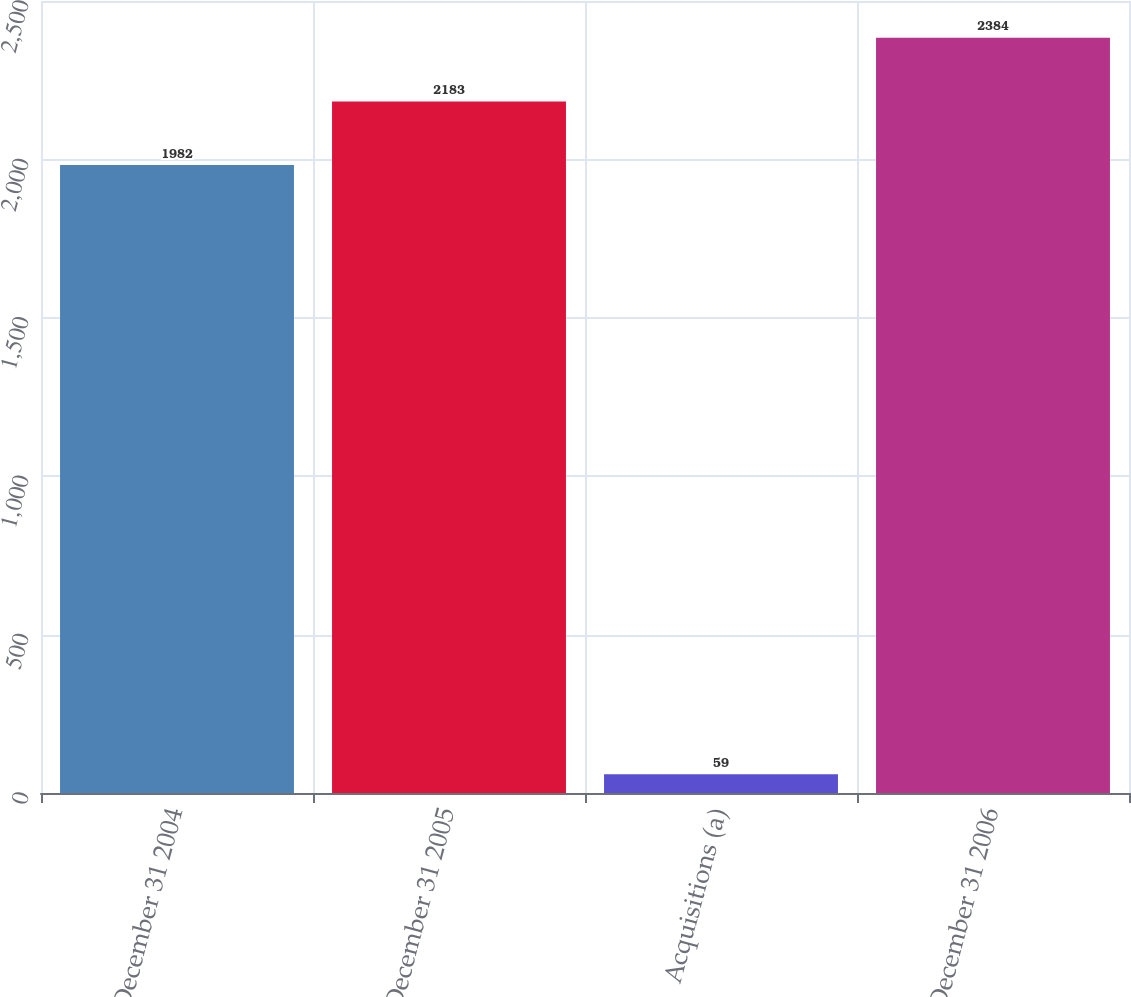<chart> <loc_0><loc_0><loc_500><loc_500><bar_chart><fcel>December 31 2004<fcel>December 31 2005<fcel>Acquisitions (a)<fcel>December 31 2006<nl><fcel>1982<fcel>2183<fcel>59<fcel>2384<nl></chart> 